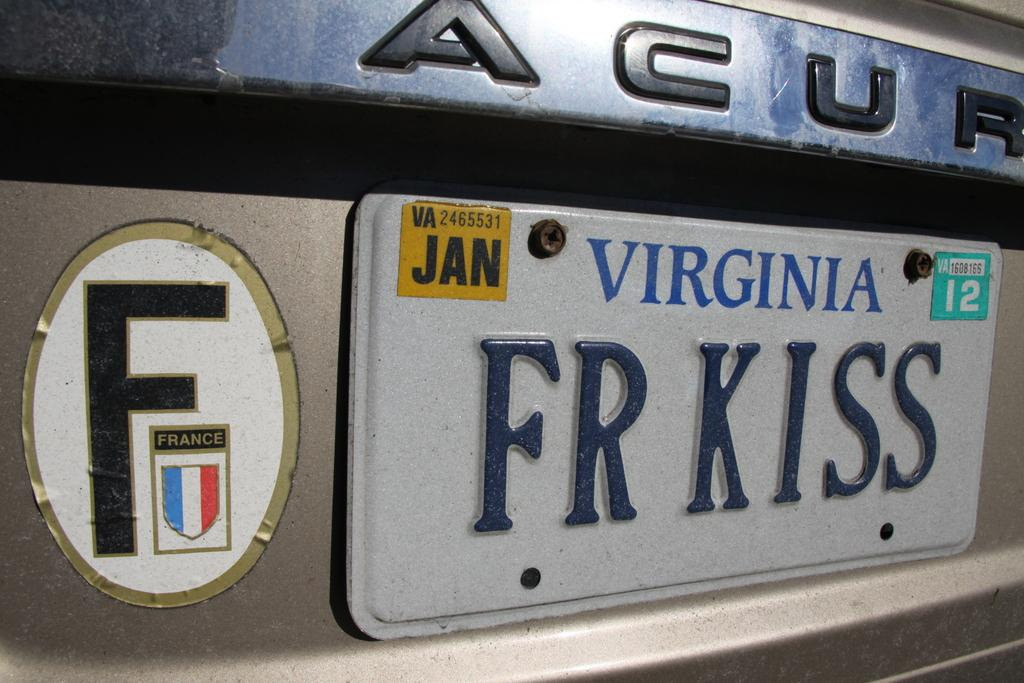<image>
Present a compact description of the photo's key features. White Virginia license plate which says FRKISS on it. 